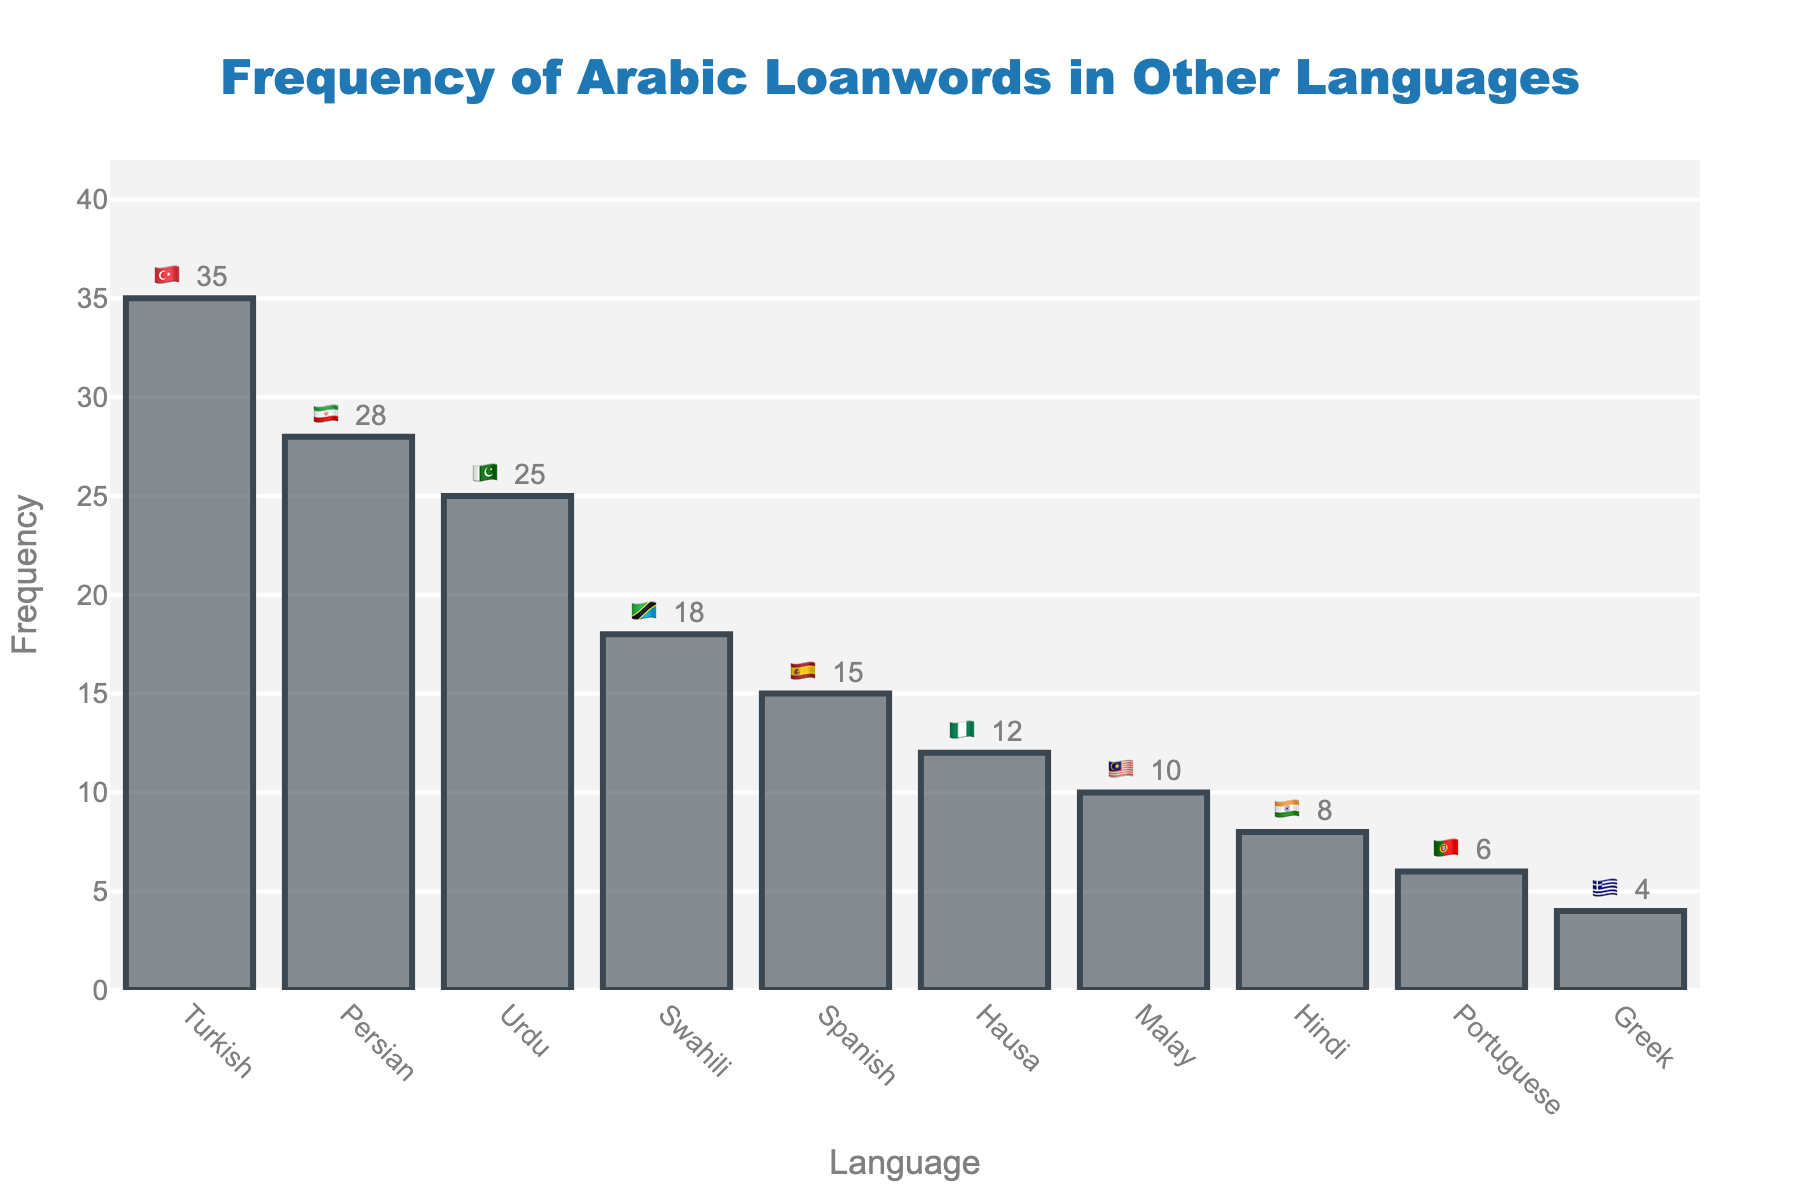What is the frequency of Arabic loanwords in Turkish? To find the frequency of Arabic loanwords in Turkish, refer to the bar labeled "Turkish" in the chart. The value shown beside the bar is "35".
Answer: 35 Which language has the lowest frequency of Arabic loanwords shown in the chart? Look at the chart to identify the bar with the smallest height. The bar labeled "Greek" has the lowest value, which is "4".
Answer: Greek Calculate the difference in the frequency of Arabic loanwords between Persian and Urdu. Find the bars for "Persian" and "Urdu" in the chart. The frequencies are 28 and 25, respectively. Subtract 25 from 28 to get the difference: 28 - 25 = 3.
Answer: 3 Which two languages have the closest frequencies of Arabic loanwords, and what are those frequencies? Identify the frequencies of all languages. Urdu (25) and Swahili (18) are close but not the closest. Hindi (8) and Portuguese (6) are also close but not the closest. Persian (28) and Urdu (25) are the closest with only a 3 frequency difference.
Answer: Persian (28) and Urdu (25) How many languages have a frequency of Arabic loanwords greater than or equal to 10? Count the bars with frequencies 10 or higher: Turkish (35), Persian (28), Urdu (25), Swahili (18), Spanish (15), Hausa (12), Malay (10). There are 7 languages in total.
Answer: 7 Which language has a frequency of Arabic loanwords exactly halfway between the highest and lowest frequencies? The highest frequency is 35 (Turkish) and the lowest is 4 (Greek). The halfway point is (35 + 4) / 2 = 19.5. Swahili has a frequency closest to this value with 18.
Answer: Swahili Rank the languages by the frequency of Arabic loanwords from highest to lowest. List each language by examining the bars from tallest to shortest: Turkish, Persian, Urdu, Swahili, Spanish, Hausa, Malay, Hindi, Portuguese, Greek.
Answer: Turkish, Persian, Urdu, Swahili, Spanish, Hausa, Malay, Hindi, Portuguese, Greek What is the combined frequency of Arabic loanwords in Spanish and Portuguese? Look at the bars for "Spanish" and "Portuguese". The frequencies are 15 and 6, respectively. Add these values: 15 + 6 = 21.
Answer: 21 Which language, represented by an emoji flag, falls between the frequencies of Hindi and Hausa? Identify the languages to find their contexts via emoji and frequency. Hindi has 8 and Hausa has 12. Malay, represented by the flag 🇲🇾, has a frequency of 10 and falls between them.
Answer: Malay (🇲🇾) What is the average frequency of Arabic loanwords in Swahili, Hindi, and Greek? Find the frequencies of Swahili (18), Hindi (8), and Greek (4). Sum these values: 18 + 8 + 4 = 30. Divide by the number of languages (3): 30 / 3 = 10.
Answer: 10 